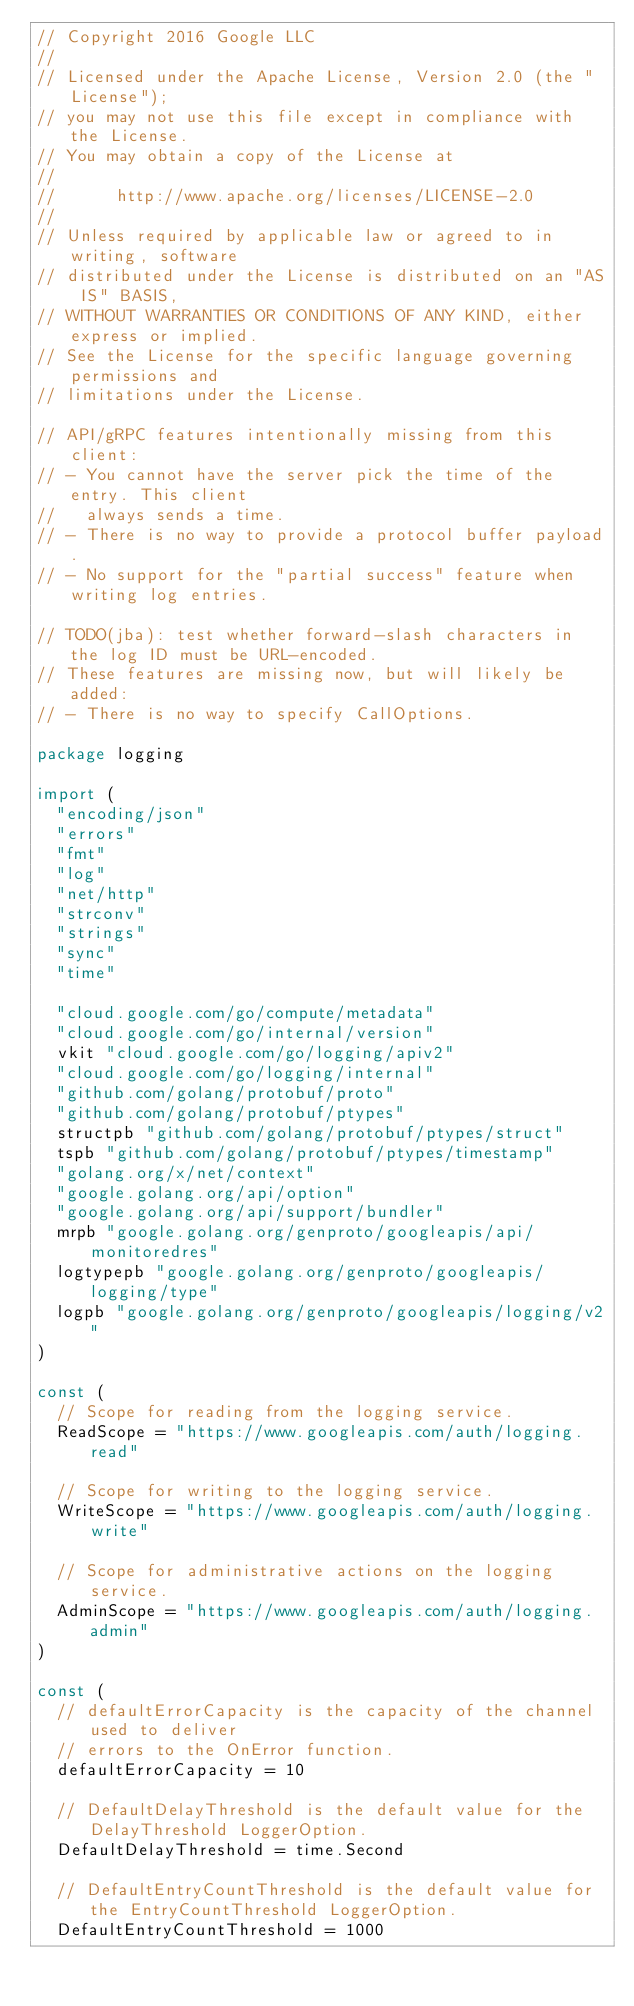<code> <loc_0><loc_0><loc_500><loc_500><_Go_>// Copyright 2016 Google LLC
//
// Licensed under the Apache License, Version 2.0 (the "License");
// you may not use this file except in compliance with the License.
// You may obtain a copy of the License at
//
//      http://www.apache.org/licenses/LICENSE-2.0
//
// Unless required by applicable law or agreed to in writing, software
// distributed under the License is distributed on an "AS IS" BASIS,
// WITHOUT WARRANTIES OR CONDITIONS OF ANY KIND, either express or implied.
// See the License for the specific language governing permissions and
// limitations under the License.

// API/gRPC features intentionally missing from this client:
// - You cannot have the server pick the time of the entry. This client
//   always sends a time.
// - There is no way to provide a protocol buffer payload.
// - No support for the "partial success" feature when writing log entries.

// TODO(jba): test whether forward-slash characters in the log ID must be URL-encoded.
// These features are missing now, but will likely be added:
// - There is no way to specify CallOptions.

package logging

import (
	"encoding/json"
	"errors"
	"fmt"
	"log"
	"net/http"
	"strconv"
	"strings"
	"sync"
	"time"

	"cloud.google.com/go/compute/metadata"
	"cloud.google.com/go/internal/version"
	vkit "cloud.google.com/go/logging/apiv2"
	"cloud.google.com/go/logging/internal"
	"github.com/golang/protobuf/proto"
	"github.com/golang/protobuf/ptypes"
	structpb "github.com/golang/protobuf/ptypes/struct"
	tspb "github.com/golang/protobuf/ptypes/timestamp"
	"golang.org/x/net/context"
	"google.golang.org/api/option"
	"google.golang.org/api/support/bundler"
	mrpb "google.golang.org/genproto/googleapis/api/monitoredres"
	logtypepb "google.golang.org/genproto/googleapis/logging/type"
	logpb "google.golang.org/genproto/googleapis/logging/v2"
)

const (
	// Scope for reading from the logging service.
	ReadScope = "https://www.googleapis.com/auth/logging.read"

	// Scope for writing to the logging service.
	WriteScope = "https://www.googleapis.com/auth/logging.write"

	// Scope for administrative actions on the logging service.
	AdminScope = "https://www.googleapis.com/auth/logging.admin"
)

const (
	// defaultErrorCapacity is the capacity of the channel used to deliver
	// errors to the OnError function.
	defaultErrorCapacity = 10

	// DefaultDelayThreshold is the default value for the DelayThreshold LoggerOption.
	DefaultDelayThreshold = time.Second

	// DefaultEntryCountThreshold is the default value for the EntryCountThreshold LoggerOption.
	DefaultEntryCountThreshold = 1000
</code> 